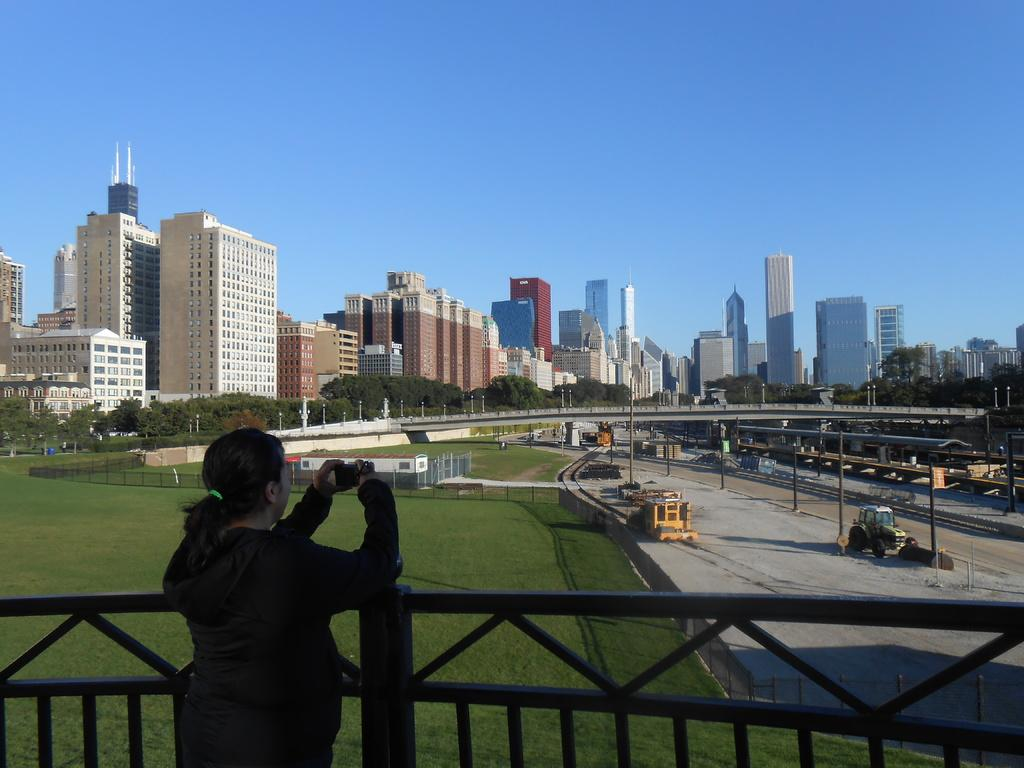What is located in the middle of the image? There are buildings and trees in the middle of the image. Can you describe the person in the image? There is a person in the middle of the image. What is visible at the top of the image? The sky is visible at the top of the image. How many eggs are being digested by the person in the image? There is no indication of eggs or digestion in the image; it only features buildings, trees, and a person. 